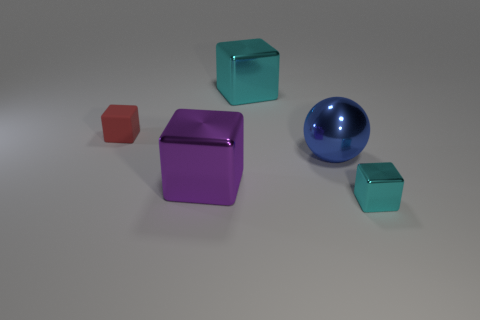Add 1 big balls. How many objects exist? 6 Subtract all blocks. How many objects are left? 1 Add 5 large purple metallic objects. How many large purple metallic objects are left? 6 Add 2 large purple metal blocks. How many large purple metal blocks exist? 3 Subtract 0 yellow cylinders. How many objects are left? 5 Subtract all brown cubes. Subtract all blocks. How many objects are left? 1 